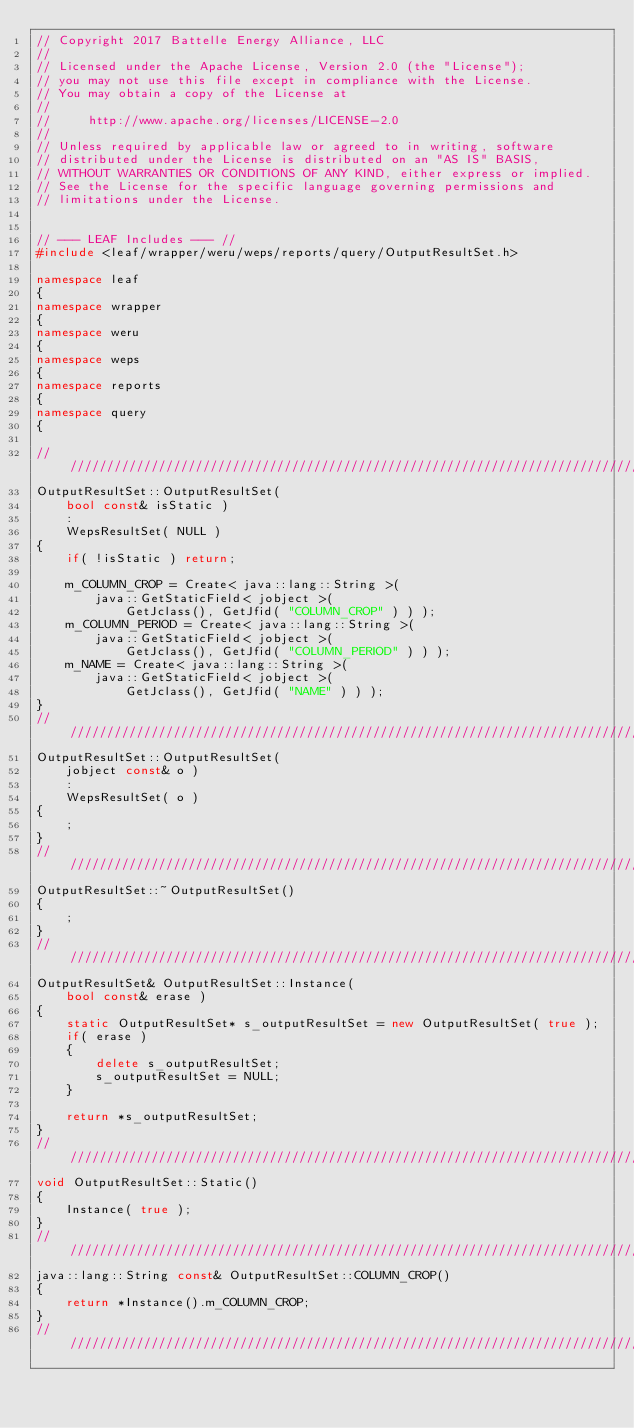<code> <loc_0><loc_0><loc_500><loc_500><_C++_>// Copyright 2017 Battelle Energy Alliance, LLC
//
// Licensed under the Apache License, Version 2.0 (the "License");
// you may not use this file except in compliance with the License.
// You may obtain a copy of the License at
//
//     http://www.apache.org/licenses/LICENSE-2.0
//
// Unless required by applicable law or agreed to in writing, software
// distributed under the License is distributed on an "AS IS" BASIS,
// WITHOUT WARRANTIES OR CONDITIONS OF ANY KIND, either express or implied.
// See the License for the specific language governing permissions and
// limitations under the License.


// --- LEAF Includes --- //
#include <leaf/wrapper/weru/weps/reports/query/OutputResultSet.h>

namespace leaf
{
namespace wrapper
{
namespace weru
{
namespace weps
{
namespace reports
{
namespace query
{

////////////////////////////////////////////////////////////////////////////////
OutputResultSet::OutputResultSet(
    bool const& isStatic )
    :
    WepsResultSet( NULL )
{
    if( !isStatic ) return;

    m_COLUMN_CROP = Create< java::lang::String >(
        java::GetStaticField< jobject >(
            GetJclass(), GetJfid( "COLUMN_CROP" ) ) );
    m_COLUMN_PERIOD = Create< java::lang::String >(
        java::GetStaticField< jobject >(
            GetJclass(), GetJfid( "COLUMN_PERIOD" ) ) );
    m_NAME = Create< java::lang::String >(
        java::GetStaticField< jobject >(
            GetJclass(), GetJfid( "NAME" ) ) );
}
////////////////////////////////////////////////////////////////////////////////
OutputResultSet::OutputResultSet(
    jobject const& o )
    :
    WepsResultSet( o )
{
    ;
}
////////////////////////////////////////////////////////////////////////////////
OutputResultSet::~OutputResultSet()
{
    ;
}
////////////////////////////////////////////////////////////////////////////////
OutputResultSet& OutputResultSet::Instance(
    bool const& erase )
{
    static OutputResultSet* s_outputResultSet = new OutputResultSet( true );
    if( erase )
    {
        delete s_outputResultSet;
        s_outputResultSet = NULL;
    }

    return *s_outputResultSet;
}
////////////////////////////////////////////////////////////////////////////////
void OutputResultSet::Static()
{
    Instance( true );
}
////////////////////////////////////////////////////////////////////////////////
java::lang::String const& OutputResultSet::COLUMN_CROP()
{
    return *Instance().m_COLUMN_CROP;
}
////////////////////////////////////////////////////////////////////////////////</code> 